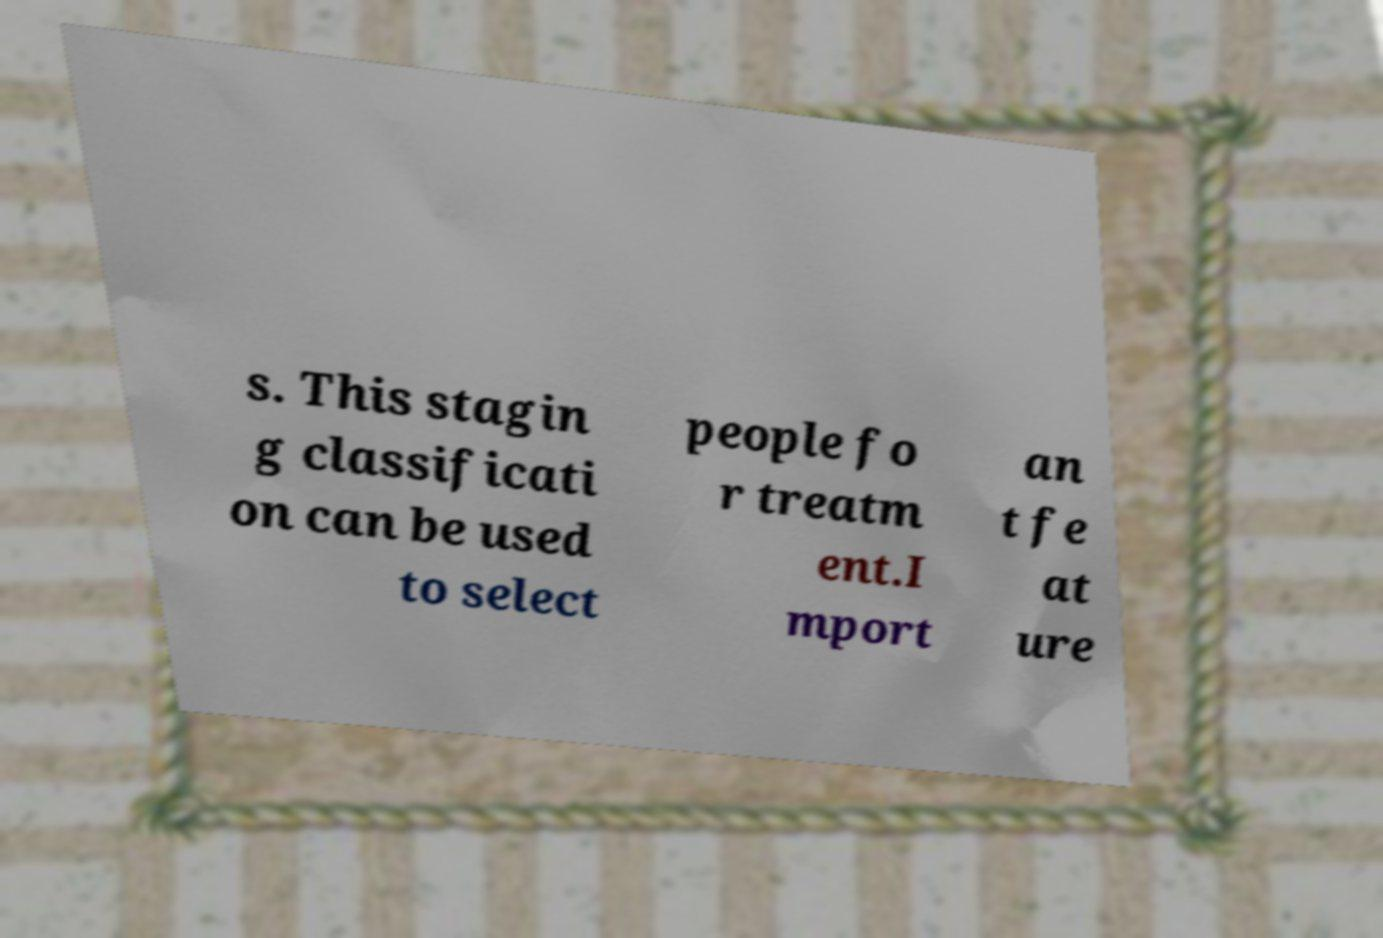There's text embedded in this image that I need extracted. Can you transcribe it verbatim? s. This stagin g classificati on can be used to select people fo r treatm ent.I mport an t fe at ure 